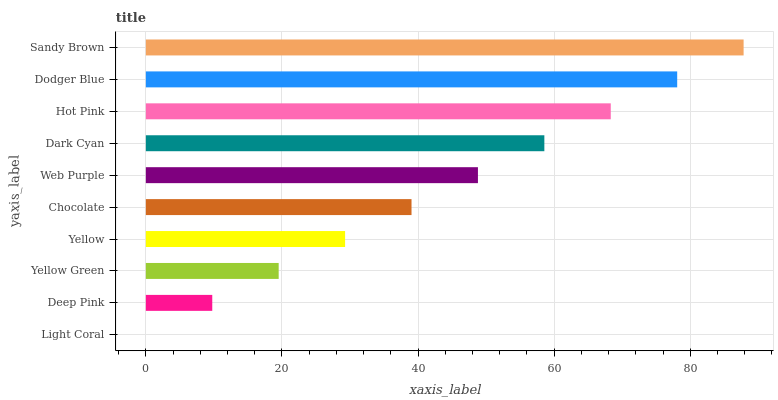Is Light Coral the minimum?
Answer yes or no. Yes. Is Sandy Brown the maximum?
Answer yes or no. Yes. Is Deep Pink the minimum?
Answer yes or no. No. Is Deep Pink the maximum?
Answer yes or no. No. Is Deep Pink greater than Light Coral?
Answer yes or no. Yes. Is Light Coral less than Deep Pink?
Answer yes or no. Yes. Is Light Coral greater than Deep Pink?
Answer yes or no. No. Is Deep Pink less than Light Coral?
Answer yes or no. No. Is Web Purple the high median?
Answer yes or no. Yes. Is Chocolate the low median?
Answer yes or no. Yes. Is Yellow the high median?
Answer yes or no. No. Is Dodger Blue the low median?
Answer yes or no. No. 